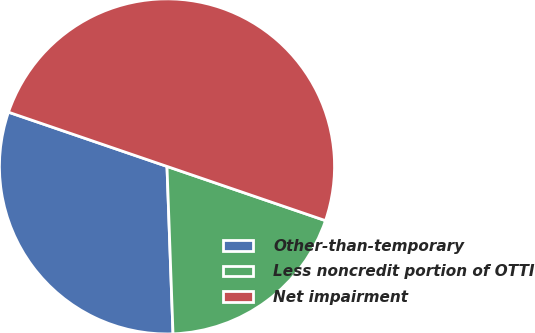Convert chart. <chart><loc_0><loc_0><loc_500><loc_500><pie_chart><fcel>Other-than-temporary<fcel>Less noncredit portion of OTTI<fcel>Net impairment<nl><fcel>30.82%<fcel>19.18%<fcel>50.0%<nl></chart> 